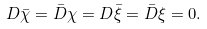<formula> <loc_0><loc_0><loc_500><loc_500>D \bar { \chi } = \bar { D } \chi = D \bar { \xi } = \bar { D } \xi = 0 .</formula> 